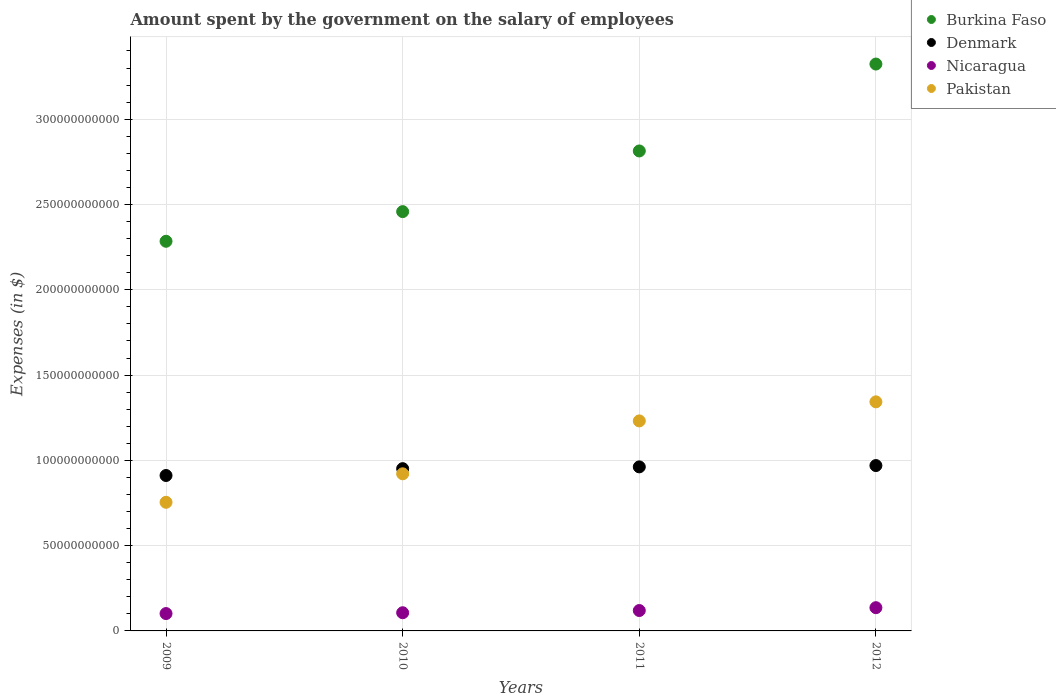How many different coloured dotlines are there?
Offer a terse response. 4. What is the amount spent on the salary of employees by the government in Nicaragua in 2010?
Your answer should be very brief. 1.07e+1. Across all years, what is the maximum amount spent on the salary of employees by the government in Nicaragua?
Your answer should be very brief. 1.36e+1. Across all years, what is the minimum amount spent on the salary of employees by the government in Denmark?
Provide a succinct answer. 9.11e+1. In which year was the amount spent on the salary of employees by the government in Burkina Faso minimum?
Make the answer very short. 2009. What is the total amount spent on the salary of employees by the government in Pakistan in the graph?
Ensure brevity in your answer.  4.25e+11. What is the difference between the amount spent on the salary of employees by the government in Denmark in 2010 and that in 2012?
Offer a terse response. -1.81e+09. What is the difference between the amount spent on the salary of employees by the government in Denmark in 2009 and the amount spent on the salary of employees by the government in Nicaragua in 2010?
Make the answer very short. 8.05e+1. What is the average amount spent on the salary of employees by the government in Denmark per year?
Offer a very short reply. 9.48e+1. In the year 2012, what is the difference between the amount spent on the salary of employees by the government in Pakistan and amount spent on the salary of employees by the government in Nicaragua?
Your response must be concise. 1.21e+11. What is the ratio of the amount spent on the salary of employees by the government in Burkina Faso in 2009 to that in 2010?
Offer a very short reply. 0.93. Is the amount spent on the salary of employees by the government in Pakistan in 2010 less than that in 2012?
Your answer should be very brief. Yes. What is the difference between the highest and the second highest amount spent on the salary of employees by the government in Denmark?
Offer a terse response. 7.71e+08. What is the difference between the highest and the lowest amount spent on the salary of employees by the government in Denmark?
Provide a short and direct response. 5.83e+09. In how many years, is the amount spent on the salary of employees by the government in Pakistan greater than the average amount spent on the salary of employees by the government in Pakistan taken over all years?
Make the answer very short. 2. Is the sum of the amount spent on the salary of employees by the government in Denmark in 2009 and 2011 greater than the maximum amount spent on the salary of employees by the government in Pakistan across all years?
Provide a short and direct response. Yes. Is it the case that in every year, the sum of the amount spent on the salary of employees by the government in Burkina Faso and amount spent on the salary of employees by the government in Pakistan  is greater than the sum of amount spent on the salary of employees by the government in Denmark and amount spent on the salary of employees by the government in Nicaragua?
Provide a short and direct response. Yes. Is the amount spent on the salary of employees by the government in Burkina Faso strictly greater than the amount spent on the salary of employees by the government in Nicaragua over the years?
Ensure brevity in your answer.  Yes. Is the amount spent on the salary of employees by the government in Burkina Faso strictly less than the amount spent on the salary of employees by the government in Denmark over the years?
Ensure brevity in your answer.  No. How many dotlines are there?
Give a very brief answer. 4. How many years are there in the graph?
Your answer should be very brief. 4. What is the difference between two consecutive major ticks on the Y-axis?
Your answer should be very brief. 5.00e+1. Does the graph contain any zero values?
Offer a very short reply. No. Where does the legend appear in the graph?
Make the answer very short. Top right. What is the title of the graph?
Provide a succinct answer. Amount spent by the government on the salary of employees. Does "Honduras" appear as one of the legend labels in the graph?
Ensure brevity in your answer.  No. What is the label or title of the Y-axis?
Make the answer very short. Expenses (in $). What is the Expenses (in $) of Burkina Faso in 2009?
Provide a succinct answer. 2.28e+11. What is the Expenses (in $) in Denmark in 2009?
Provide a short and direct response. 9.11e+1. What is the Expenses (in $) in Nicaragua in 2009?
Keep it short and to the point. 1.02e+1. What is the Expenses (in $) in Pakistan in 2009?
Make the answer very short. 7.54e+1. What is the Expenses (in $) of Burkina Faso in 2010?
Provide a short and direct response. 2.46e+11. What is the Expenses (in $) in Denmark in 2010?
Your response must be concise. 9.51e+1. What is the Expenses (in $) in Nicaragua in 2010?
Provide a short and direct response. 1.07e+1. What is the Expenses (in $) of Pakistan in 2010?
Your answer should be very brief. 9.21e+1. What is the Expenses (in $) in Burkina Faso in 2011?
Your answer should be compact. 2.81e+11. What is the Expenses (in $) of Denmark in 2011?
Ensure brevity in your answer.  9.62e+1. What is the Expenses (in $) in Nicaragua in 2011?
Your answer should be very brief. 1.20e+1. What is the Expenses (in $) of Pakistan in 2011?
Your answer should be very brief. 1.23e+11. What is the Expenses (in $) of Burkina Faso in 2012?
Give a very brief answer. 3.32e+11. What is the Expenses (in $) in Denmark in 2012?
Your answer should be very brief. 9.69e+1. What is the Expenses (in $) in Nicaragua in 2012?
Make the answer very short. 1.36e+1. What is the Expenses (in $) of Pakistan in 2012?
Provide a succinct answer. 1.34e+11. Across all years, what is the maximum Expenses (in $) of Burkina Faso?
Keep it short and to the point. 3.32e+11. Across all years, what is the maximum Expenses (in $) in Denmark?
Provide a short and direct response. 9.69e+1. Across all years, what is the maximum Expenses (in $) of Nicaragua?
Ensure brevity in your answer.  1.36e+1. Across all years, what is the maximum Expenses (in $) of Pakistan?
Your response must be concise. 1.34e+11. Across all years, what is the minimum Expenses (in $) in Burkina Faso?
Your response must be concise. 2.28e+11. Across all years, what is the minimum Expenses (in $) of Denmark?
Give a very brief answer. 9.11e+1. Across all years, what is the minimum Expenses (in $) of Nicaragua?
Your answer should be compact. 1.02e+1. Across all years, what is the minimum Expenses (in $) of Pakistan?
Provide a short and direct response. 7.54e+1. What is the total Expenses (in $) in Burkina Faso in the graph?
Keep it short and to the point. 1.09e+12. What is the total Expenses (in $) of Denmark in the graph?
Offer a terse response. 3.79e+11. What is the total Expenses (in $) of Nicaragua in the graph?
Provide a short and direct response. 4.64e+1. What is the total Expenses (in $) in Pakistan in the graph?
Provide a short and direct response. 4.25e+11. What is the difference between the Expenses (in $) in Burkina Faso in 2009 and that in 2010?
Make the answer very short. -1.74e+1. What is the difference between the Expenses (in $) in Denmark in 2009 and that in 2010?
Your answer should be compact. -4.02e+09. What is the difference between the Expenses (in $) of Nicaragua in 2009 and that in 2010?
Offer a very short reply. -4.83e+08. What is the difference between the Expenses (in $) in Pakistan in 2009 and that in 2010?
Keep it short and to the point. -1.67e+1. What is the difference between the Expenses (in $) of Burkina Faso in 2009 and that in 2011?
Ensure brevity in your answer.  -5.30e+1. What is the difference between the Expenses (in $) in Denmark in 2009 and that in 2011?
Your response must be concise. -5.06e+09. What is the difference between the Expenses (in $) in Nicaragua in 2009 and that in 2011?
Your response must be concise. -1.78e+09. What is the difference between the Expenses (in $) in Pakistan in 2009 and that in 2011?
Provide a succinct answer. -4.77e+1. What is the difference between the Expenses (in $) of Burkina Faso in 2009 and that in 2012?
Offer a terse response. -1.04e+11. What is the difference between the Expenses (in $) in Denmark in 2009 and that in 2012?
Your answer should be compact. -5.83e+09. What is the difference between the Expenses (in $) in Nicaragua in 2009 and that in 2012?
Your answer should be very brief. -3.45e+09. What is the difference between the Expenses (in $) of Pakistan in 2009 and that in 2012?
Ensure brevity in your answer.  -5.89e+1. What is the difference between the Expenses (in $) of Burkina Faso in 2010 and that in 2011?
Provide a succinct answer. -3.56e+1. What is the difference between the Expenses (in $) of Denmark in 2010 and that in 2011?
Your answer should be very brief. -1.04e+09. What is the difference between the Expenses (in $) of Nicaragua in 2010 and that in 2011?
Offer a terse response. -1.30e+09. What is the difference between the Expenses (in $) of Pakistan in 2010 and that in 2011?
Make the answer very short. -3.10e+1. What is the difference between the Expenses (in $) of Burkina Faso in 2010 and that in 2012?
Ensure brevity in your answer.  -8.65e+1. What is the difference between the Expenses (in $) in Denmark in 2010 and that in 2012?
Your answer should be very brief. -1.81e+09. What is the difference between the Expenses (in $) in Nicaragua in 2010 and that in 2012?
Your answer should be compact. -2.97e+09. What is the difference between the Expenses (in $) in Pakistan in 2010 and that in 2012?
Keep it short and to the point. -4.22e+1. What is the difference between the Expenses (in $) of Burkina Faso in 2011 and that in 2012?
Offer a very short reply. -5.10e+1. What is the difference between the Expenses (in $) of Denmark in 2011 and that in 2012?
Provide a succinct answer. -7.71e+08. What is the difference between the Expenses (in $) of Nicaragua in 2011 and that in 2012?
Your answer should be compact. -1.67e+09. What is the difference between the Expenses (in $) of Pakistan in 2011 and that in 2012?
Offer a very short reply. -1.12e+1. What is the difference between the Expenses (in $) in Burkina Faso in 2009 and the Expenses (in $) in Denmark in 2010?
Your answer should be very brief. 1.33e+11. What is the difference between the Expenses (in $) in Burkina Faso in 2009 and the Expenses (in $) in Nicaragua in 2010?
Offer a terse response. 2.18e+11. What is the difference between the Expenses (in $) of Burkina Faso in 2009 and the Expenses (in $) of Pakistan in 2010?
Keep it short and to the point. 1.36e+11. What is the difference between the Expenses (in $) in Denmark in 2009 and the Expenses (in $) in Nicaragua in 2010?
Give a very brief answer. 8.05e+1. What is the difference between the Expenses (in $) of Denmark in 2009 and the Expenses (in $) of Pakistan in 2010?
Provide a short and direct response. -9.97e+08. What is the difference between the Expenses (in $) in Nicaragua in 2009 and the Expenses (in $) in Pakistan in 2010?
Ensure brevity in your answer.  -8.19e+1. What is the difference between the Expenses (in $) of Burkina Faso in 2009 and the Expenses (in $) of Denmark in 2011?
Your answer should be compact. 1.32e+11. What is the difference between the Expenses (in $) in Burkina Faso in 2009 and the Expenses (in $) in Nicaragua in 2011?
Keep it short and to the point. 2.16e+11. What is the difference between the Expenses (in $) of Burkina Faso in 2009 and the Expenses (in $) of Pakistan in 2011?
Provide a short and direct response. 1.05e+11. What is the difference between the Expenses (in $) in Denmark in 2009 and the Expenses (in $) in Nicaragua in 2011?
Keep it short and to the point. 7.92e+1. What is the difference between the Expenses (in $) in Denmark in 2009 and the Expenses (in $) in Pakistan in 2011?
Offer a terse response. -3.20e+1. What is the difference between the Expenses (in $) in Nicaragua in 2009 and the Expenses (in $) in Pakistan in 2011?
Your answer should be very brief. -1.13e+11. What is the difference between the Expenses (in $) of Burkina Faso in 2009 and the Expenses (in $) of Denmark in 2012?
Give a very brief answer. 1.31e+11. What is the difference between the Expenses (in $) of Burkina Faso in 2009 and the Expenses (in $) of Nicaragua in 2012?
Offer a terse response. 2.15e+11. What is the difference between the Expenses (in $) in Burkina Faso in 2009 and the Expenses (in $) in Pakistan in 2012?
Offer a terse response. 9.41e+1. What is the difference between the Expenses (in $) of Denmark in 2009 and the Expenses (in $) of Nicaragua in 2012?
Provide a succinct answer. 7.75e+1. What is the difference between the Expenses (in $) of Denmark in 2009 and the Expenses (in $) of Pakistan in 2012?
Provide a succinct answer. -4.32e+1. What is the difference between the Expenses (in $) of Nicaragua in 2009 and the Expenses (in $) of Pakistan in 2012?
Ensure brevity in your answer.  -1.24e+11. What is the difference between the Expenses (in $) of Burkina Faso in 2010 and the Expenses (in $) of Denmark in 2011?
Your answer should be compact. 1.50e+11. What is the difference between the Expenses (in $) of Burkina Faso in 2010 and the Expenses (in $) of Nicaragua in 2011?
Your answer should be very brief. 2.34e+11. What is the difference between the Expenses (in $) of Burkina Faso in 2010 and the Expenses (in $) of Pakistan in 2011?
Offer a terse response. 1.23e+11. What is the difference between the Expenses (in $) in Denmark in 2010 and the Expenses (in $) in Nicaragua in 2011?
Give a very brief answer. 8.32e+1. What is the difference between the Expenses (in $) of Denmark in 2010 and the Expenses (in $) of Pakistan in 2011?
Offer a terse response. -2.80e+1. What is the difference between the Expenses (in $) in Nicaragua in 2010 and the Expenses (in $) in Pakistan in 2011?
Provide a short and direct response. -1.12e+11. What is the difference between the Expenses (in $) in Burkina Faso in 2010 and the Expenses (in $) in Denmark in 2012?
Make the answer very short. 1.49e+11. What is the difference between the Expenses (in $) of Burkina Faso in 2010 and the Expenses (in $) of Nicaragua in 2012?
Ensure brevity in your answer.  2.32e+11. What is the difference between the Expenses (in $) of Burkina Faso in 2010 and the Expenses (in $) of Pakistan in 2012?
Give a very brief answer. 1.12e+11. What is the difference between the Expenses (in $) in Denmark in 2010 and the Expenses (in $) in Nicaragua in 2012?
Ensure brevity in your answer.  8.15e+1. What is the difference between the Expenses (in $) of Denmark in 2010 and the Expenses (in $) of Pakistan in 2012?
Offer a very short reply. -3.92e+1. What is the difference between the Expenses (in $) of Nicaragua in 2010 and the Expenses (in $) of Pakistan in 2012?
Provide a short and direct response. -1.24e+11. What is the difference between the Expenses (in $) in Burkina Faso in 2011 and the Expenses (in $) in Denmark in 2012?
Ensure brevity in your answer.  1.84e+11. What is the difference between the Expenses (in $) of Burkina Faso in 2011 and the Expenses (in $) of Nicaragua in 2012?
Make the answer very short. 2.68e+11. What is the difference between the Expenses (in $) in Burkina Faso in 2011 and the Expenses (in $) in Pakistan in 2012?
Your response must be concise. 1.47e+11. What is the difference between the Expenses (in $) of Denmark in 2011 and the Expenses (in $) of Nicaragua in 2012?
Make the answer very short. 8.25e+1. What is the difference between the Expenses (in $) in Denmark in 2011 and the Expenses (in $) in Pakistan in 2012?
Offer a very short reply. -3.81e+1. What is the difference between the Expenses (in $) of Nicaragua in 2011 and the Expenses (in $) of Pakistan in 2012?
Provide a succinct answer. -1.22e+11. What is the average Expenses (in $) in Burkina Faso per year?
Offer a terse response. 2.72e+11. What is the average Expenses (in $) of Denmark per year?
Your answer should be very brief. 9.48e+1. What is the average Expenses (in $) in Nicaragua per year?
Keep it short and to the point. 1.16e+1. What is the average Expenses (in $) of Pakistan per year?
Give a very brief answer. 1.06e+11. In the year 2009, what is the difference between the Expenses (in $) in Burkina Faso and Expenses (in $) in Denmark?
Your answer should be very brief. 1.37e+11. In the year 2009, what is the difference between the Expenses (in $) of Burkina Faso and Expenses (in $) of Nicaragua?
Your answer should be very brief. 2.18e+11. In the year 2009, what is the difference between the Expenses (in $) in Burkina Faso and Expenses (in $) in Pakistan?
Keep it short and to the point. 1.53e+11. In the year 2009, what is the difference between the Expenses (in $) of Denmark and Expenses (in $) of Nicaragua?
Offer a terse response. 8.09e+1. In the year 2009, what is the difference between the Expenses (in $) in Denmark and Expenses (in $) in Pakistan?
Ensure brevity in your answer.  1.57e+1. In the year 2009, what is the difference between the Expenses (in $) of Nicaragua and Expenses (in $) of Pakistan?
Offer a very short reply. -6.52e+1. In the year 2010, what is the difference between the Expenses (in $) of Burkina Faso and Expenses (in $) of Denmark?
Your answer should be very brief. 1.51e+11. In the year 2010, what is the difference between the Expenses (in $) of Burkina Faso and Expenses (in $) of Nicaragua?
Your answer should be very brief. 2.35e+11. In the year 2010, what is the difference between the Expenses (in $) in Burkina Faso and Expenses (in $) in Pakistan?
Keep it short and to the point. 1.54e+11. In the year 2010, what is the difference between the Expenses (in $) in Denmark and Expenses (in $) in Nicaragua?
Keep it short and to the point. 8.45e+1. In the year 2010, what is the difference between the Expenses (in $) of Denmark and Expenses (in $) of Pakistan?
Your answer should be compact. 3.02e+09. In the year 2010, what is the difference between the Expenses (in $) of Nicaragua and Expenses (in $) of Pakistan?
Ensure brevity in your answer.  -8.15e+1. In the year 2011, what is the difference between the Expenses (in $) in Burkina Faso and Expenses (in $) in Denmark?
Offer a very short reply. 1.85e+11. In the year 2011, what is the difference between the Expenses (in $) of Burkina Faso and Expenses (in $) of Nicaragua?
Make the answer very short. 2.69e+11. In the year 2011, what is the difference between the Expenses (in $) of Burkina Faso and Expenses (in $) of Pakistan?
Your response must be concise. 1.58e+11. In the year 2011, what is the difference between the Expenses (in $) in Denmark and Expenses (in $) in Nicaragua?
Give a very brief answer. 8.42e+1. In the year 2011, what is the difference between the Expenses (in $) in Denmark and Expenses (in $) in Pakistan?
Your answer should be compact. -2.69e+1. In the year 2011, what is the difference between the Expenses (in $) of Nicaragua and Expenses (in $) of Pakistan?
Your response must be concise. -1.11e+11. In the year 2012, what is the difference between the Expenses (in $) in Burkina Faso and Expenses (in $) in Denmark?
Your answer should be compact. 2.35e+11. In the year 2012, what is the difference between the Expenses (in $) in Burkina Faso and Expenses (in $) in Nicaragua?
Provide a short and direct response. 3.19e+11. In the year 2012, what is the difference between the Expenses (in $) of Burkina Faso and Expenses (in $) of Pakistan?
Provide a short and direct response. 1.98e+11. In the year 2012, what is the difference between the Expenses (in $) of Denmark and Expenses (in $) of Nicaragua?
Provide a short and direct response. 8.33e+1. In the year 2012, what is the difference between the Expenses (in $) of Denmark and Expenses (in $) of Pakistan?
Your answer should be very brief. -3.74e+1. In the year 2012, what is the difference between the Expenses (in $) in Nicaragua and Expenses (in $) in Pakistan?
Ensure brevity in your answer.  -1.21e+11. What is the ratio of the Expenses (in $) in Burkina Faso in 2009 to that in 2010?
Keep it short and to the point. 0.93. What is the ratio of the Expenses (in $) in Denmark in 2009 to that in 2010?
Provide a succinct answer. 0.96. What is the ratio of the Expenses (in $) of Nicaragua in 2009 to that in 2010?
Give a very brief answer. 0.95. What is the ratio of the Expenses (in $) in Pakistan in 2009 to that in 2010?
Provide a succinct answer. 0.82. What is the ratio of the Expenses (in $) of Burkina Faso in 2009 to that in 2011?
Ensure brevity in your answer.  0.81. What is the ratio of the Expenses (in $) of Denmark in 2009 to that in 2011?
Your answer should be very brief. 0.95. What is the ratio of the Expenses (in $) in Nicaragua in 2009 to that in 2011?
Give a very brief answer. 0.85. What is the ratio of the Expenses (in $) in Pakistan in 2009 to that in 2011?
Make the answer very short. 0.61. What is the ratio of the Expenses (in $) of Burkina Faso in 2009 to that in 2012?
Your response must be concise. 0.69. What is the ratio of the Expenses (in $) of Denmark in 2009 to that in 2012?
Your answer should be very brief. 0.94. What is the ratio of the Expenses (in $) in Nicaragua in 2009 to that in 2012?
Give a very brief answer. 0.75. What is the ratio of the Expenses (in $) in Pakistan in 2009 to that in 2012?
Provide a short and direct response. 0.56. What is the ratio of the Expenses (in $) of Burkina Faso in 2010 to that in 2011?
Keep it short and to the point. 0.87. What is the ratio of the Expenses (in $) of Nicaragua in 2010 to that in 2011?
Offer a very short reply. 0.89. What is the ratio of the Expenses (in $) in Pakistan in 2010 to that in 2011?
Provide a short and direct response. 0.75. What is the ratio of the Expenses (in $) in Burkina Faso in 2010 to that in 2012?
Your answer should be compact. 0.74. What is the ratio of the Expenses (in $) in Denmark in 2010 to that in 2012?
Make the answer very short. 0.98. What is the ratio of the Expenses (in $) in Nicaragua in 2010 to that in 2012?
Keep it short and to the point. 0.78. What is the ratio of the Expenses (in $) in Pakistan in 2010 to that in 2012?
Keep it short and to the point. 0.69. What is the ratio of the Expenses (in $) in Burkina Faso in 2011 to that in 2012?
Give a very brief answer. 0.85. What is the ratio of the Expenses (in $) in Denmark in 2011 to that in 2012?
Offer a terse response. 0.99. What is the ratio of the Expenses (in $) in Nicaragua in 2011 to that in 2012?
Keep it short and to the point. 0.88. What is the ratio of the Expenses (in $) in Pakistan in 2011 to that in 2012?
Offer a terse response. 0.92. What is the difference between the highest and the second highest Expenses (in $) of Burkina Faso?
Make the answer very short. 5.10e+1. What is the difference between the highest and the second highest Expenses (in $) of Denmark?
Make the answer very short. 7.71e+08. What is the difference between the highest and the second highest Expenses (in $) of Nicaragua?
Provide a short and direct response. 1.67e+09. What is the difference between the highest and the second highest Expenses (in $) in Pakistan?
Your answer should be compact. 1.12e+1. What is the difference between the highest and the lowest Expenses (in $) in Burkina Faso?
Your answer should be compact. 1.04e+11. What is the difference between the highest and the lowest Expenses (in $) of Denmark?
Make the answer very short. 5.83e+09. What is the difference between the highest and the lowest Expenses (in $) in Nicaragua?
Provide a short and direct response. 3.45e+09. What is the difference between the highest and the lowest Expenses (in $) in Pakistan?
Provide a succinct answer. 5.89e+1. 